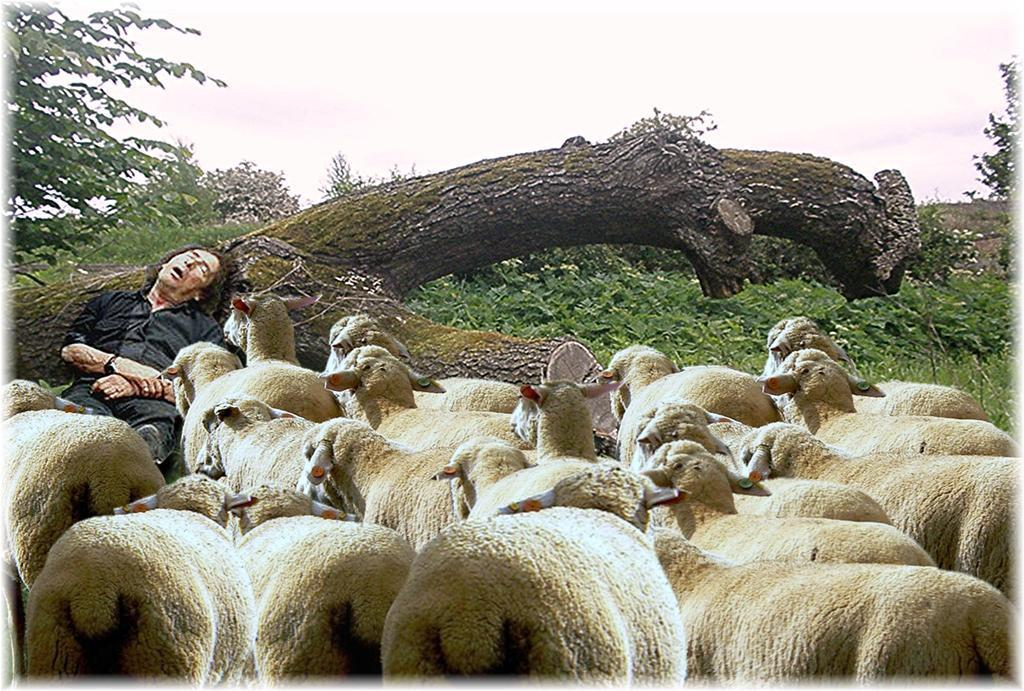What type of animals are in the image? There are sheep in the image. What color are the sheep? The sheep are cream-colored. What can be seen in the background of the image? There is a sky, clouds, trees, and a person sleeping in the background of the image. Are there any other objects visible in the background of the image? Yes, there are other objects in the background of the image. What type of quartz can be seen in the image? There is no quartz present in the image. How many oranges are visible in the image? There are no oranges present in the image. 